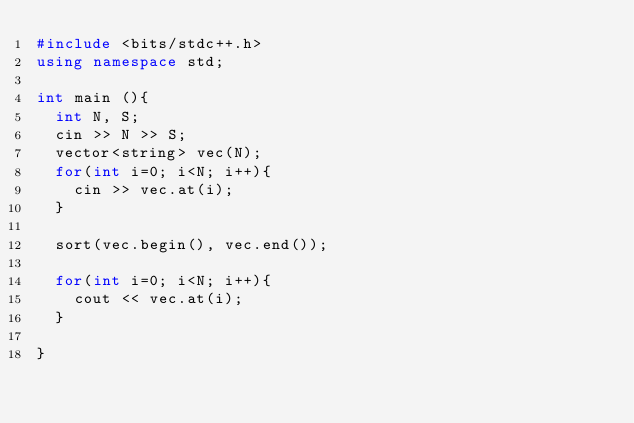<code> <loc_0><loc_0><loc_500><loc_500><_C++_>#include <bits/stdc++.h>
using namespace std;

int main (){
  int N, S;
  cin >> N >> S;
  vector<string> vec(N);
  for(int i=0; i<N; i++){
    cin >> vec.at(i);
  }
  
  sort(vec.begin(), vec.end());
  
  for(int i=0; i<N; i++){
    cout << vec.at(i);
  }

}</code> 